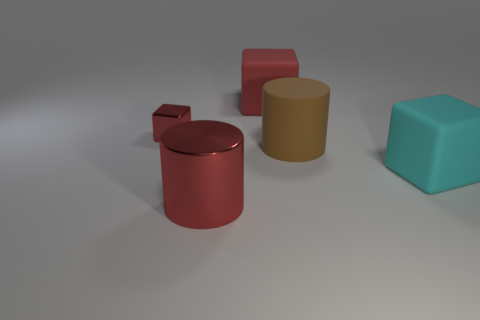There is a large thing on the left side of the large red matte cube; is its shape the same as the large brown rubber object right of the metallic cube?
Keep it short and to the point. Yes. There is a big matte cube that is to the left of the large cyan matte thing to the right of the cylinder that is in front of the big cyan rubber object; what color is it?
Provide a succinct answer. Red. There is a large cylinder behind the cyan cube; what color is it?
Provide a short and direct response. Brown. There is a matte cylinder that is the same size as the metal cylinder; what is its color?
Keep it short and to the point. Brown. Do the brown rubber cylinder and the red metal cube have the same size?
Your answer should be very brief. No. How many tiny things are on the right side of the big brown thing?
Your response must be concise. 0. How many things are large things that are to the left of the large red rubber block or red objects?
Your answer should be very brief. 3. Are there more big rubber cubes in front of the big brown rubber object than large brown rubber cylinders that are in front of the red metal cylinder?
Ensure brevity in your answer.  Yes. There is a metal thing that is the same color as the big metallic cylinder; what is its size?
Make the answer very short. Small. Is the size of the red metal cube the same as the matte cube that is behind the large cyan rubber object?
Your answer should be very brief. No. 